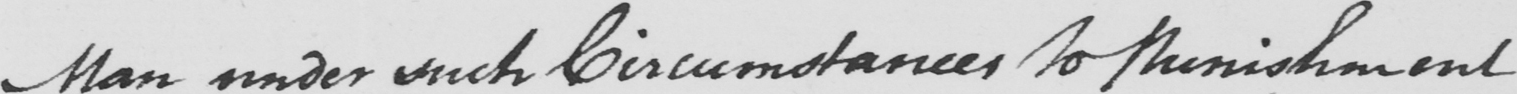What is written in this line of handwriting? Man under such Circumstances to Punishment 